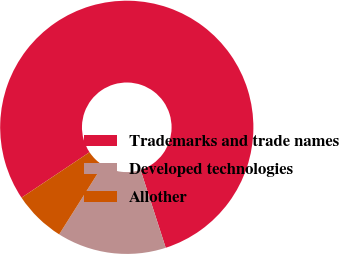Convert chart to OTSL. <chart><loc_0><loc_0><loc_500><loc_500><pie_chart><fcel>Trademarks and trade names<fcel>Developed technologies<fcel>Allother<nl><fcel>79.4%<fcel>13.94%<fcel>6.66%<nl></chart> 